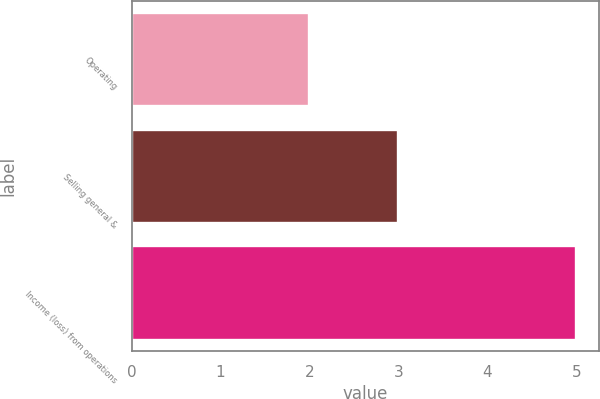<chart> <loc_0><loc_0><loc_500><loc_500><bar_chart><fcel>Operating<fcel>Selling general &<fcel>Income (loss) from operations<nl><fcel>2<fcel>3<fcel>5<nl></chart> 